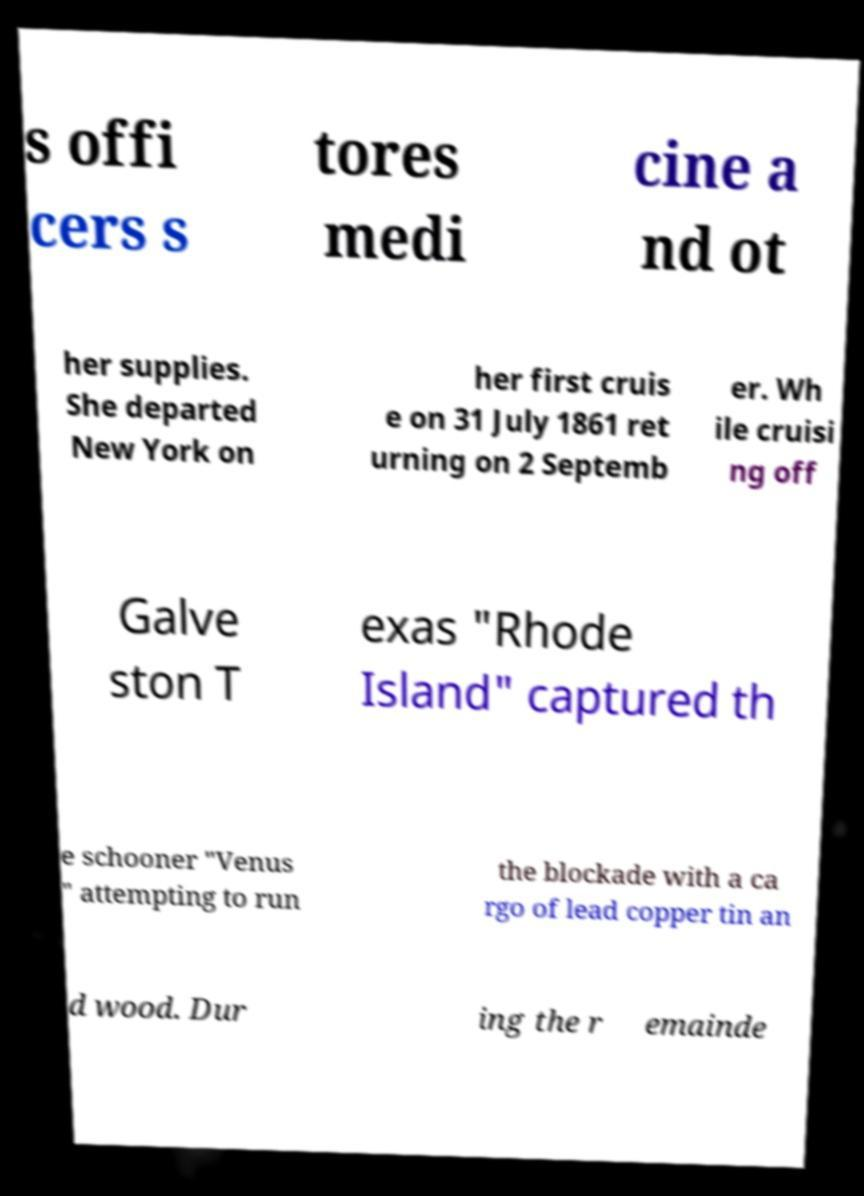Could you extract and type out the text from this image? s offi cers s tores medi cine a nd ot her supplies. She departed New York on her first cruis e on 31 July 1861 ret urning on 2 Septemb er. Wh ile cruisi ng off Galve ston T exas "Rhode Island" captured th e schooner "Venus " attempting to run the blockade with a ca rgo of lead copper tin an d wood. Dur ing the r emainde 